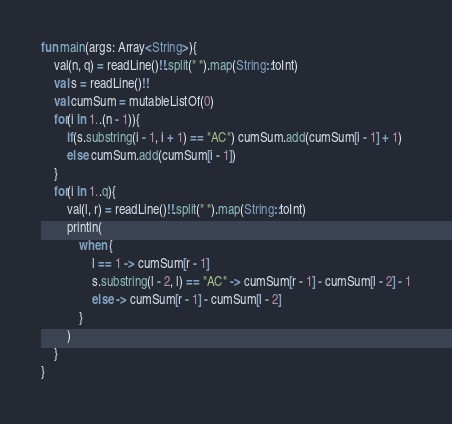Convert code to text. <code><loc_0><loc_0><loc_500><loc_500><_Kotlin_>fun main(args: Array<String>){
    val(n, q) = readLine()!!.split(" ").map(String::toInt)
    val s = readLine()!!
    val cumSum = mutableListOf(0)
    for(i in 1..(n - 1)){
        if(s.substring(i - 1, i + 1) == "AC") cumSum.add(cumSum[i - 1] + 1)
        else cumSum.add(cumSum[i - 1])
    }
    for(i in 1..q){
        val(l, r) = readLine()!!.split(" ").map(String::toInt)
        println(
            when {
                l == 1 -> cumSum[r - 1]
                s.substring(l - 2, l) == "AC" -> cumSum[r - 1] - cumSum[l - 2] - 1
                else -> cumSum[r - 1] - cumSum[l - 2]
            }
        )
    }
}</code> 